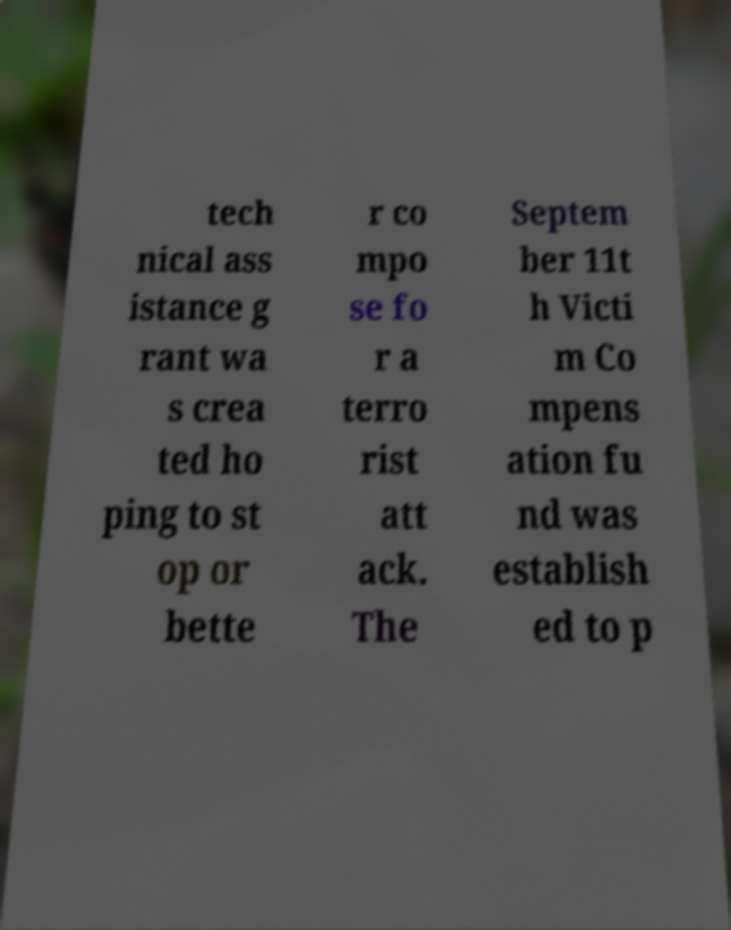Could you assist in decoding the text presented in this image and type it out clearly? tech nical ass istance g rant wa s crea ted ho ping to st op or bette r co mpo se fo r a terro rist att ack. The Septem ber 11t h Victi m Co mpens ation fu nd was establish ed to p 